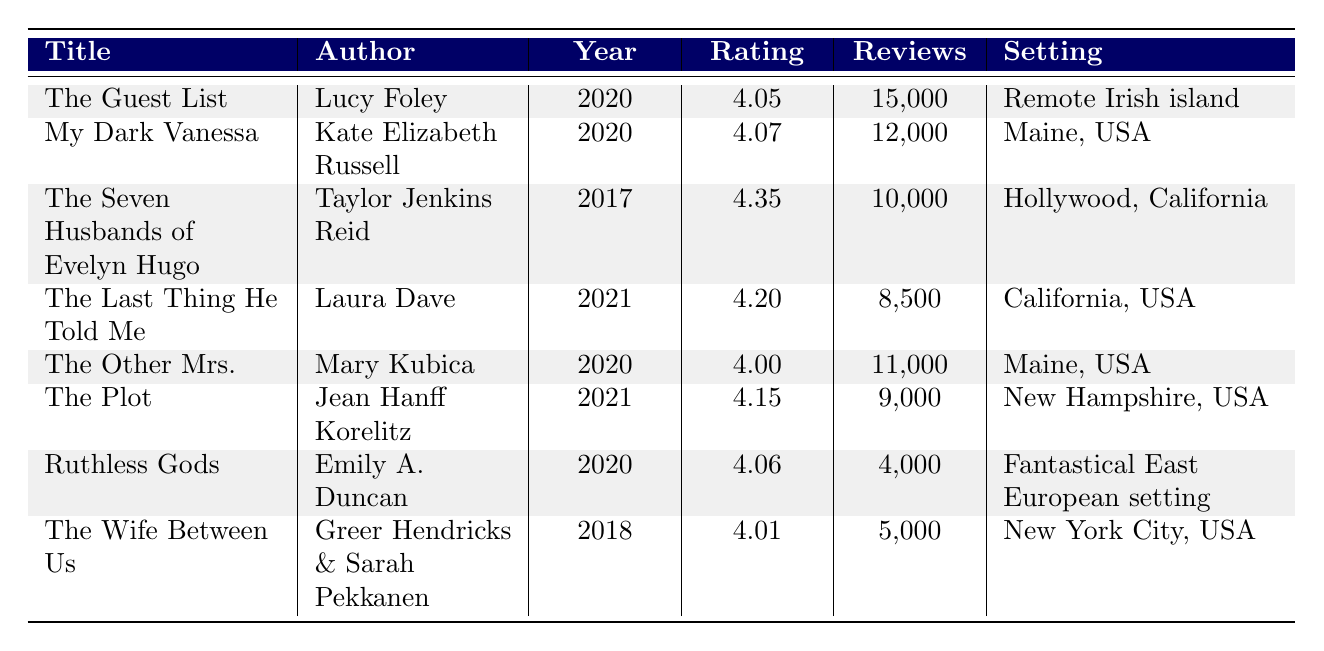What is the title of the highest-rated crime fiction title by a debut author? The table shows various titles, and the highest-rated debut crime fiction title is "My Dark Vanessa" with an average rating of 4.07.
Answer: My Dark Vanessa How many reviews did "The Guest List" receive? According to the table, "The Guest List" received 15,000 reviews.
Answer: 15,000 What is the average rating of debut crime fiction titles in the table? The average rating of the debut titles is calculated as (4.05 + 4.07 + 4.06) / 3 = 4.06. Therefore, the average rating is 4.06.
Answer: 4.06 Is "Ruthless Gods" a debut novel? The table indicates that "Ruthless Gods" is marked as a debut author, confirming it is indeed a debut novel.
Answer: Yes Which debut author has the setting in Maine, USA? From the table, "My Dark Vanessa" is the only debut title set in Maine, USA.
Answer: My Dark Vanessa How many total reviews do debut authors have? The total reviews for debut authors can be calculated as follows: 15,000 (The Guest List) + 12,000 (My Dark Vanessa) + 4,000 (Ruthless Gods) = 31,000.
Answer: 31,000 What is the lowest average rating among the listed crime fiction titles by debut authors? By comparing the average ratings of the debut titles in the table, "The Guest List" has the lowest rating at 4.05.
Answer: 4.05 Which title was published in 2021 and has an average rating higher than 4.10? The table shows "The Last Thing He Told Me" was published in 2021 with a rating of 4.20, which is higher than 4.10.
Answer: The Last Thing He Told Me How many debut authors have a novel set in a fantastical setting? From the table, only one debut author, Emily A. Duncan with "Ruthless Gods," has a novel set in a fantastical setting.
Answer: 1 